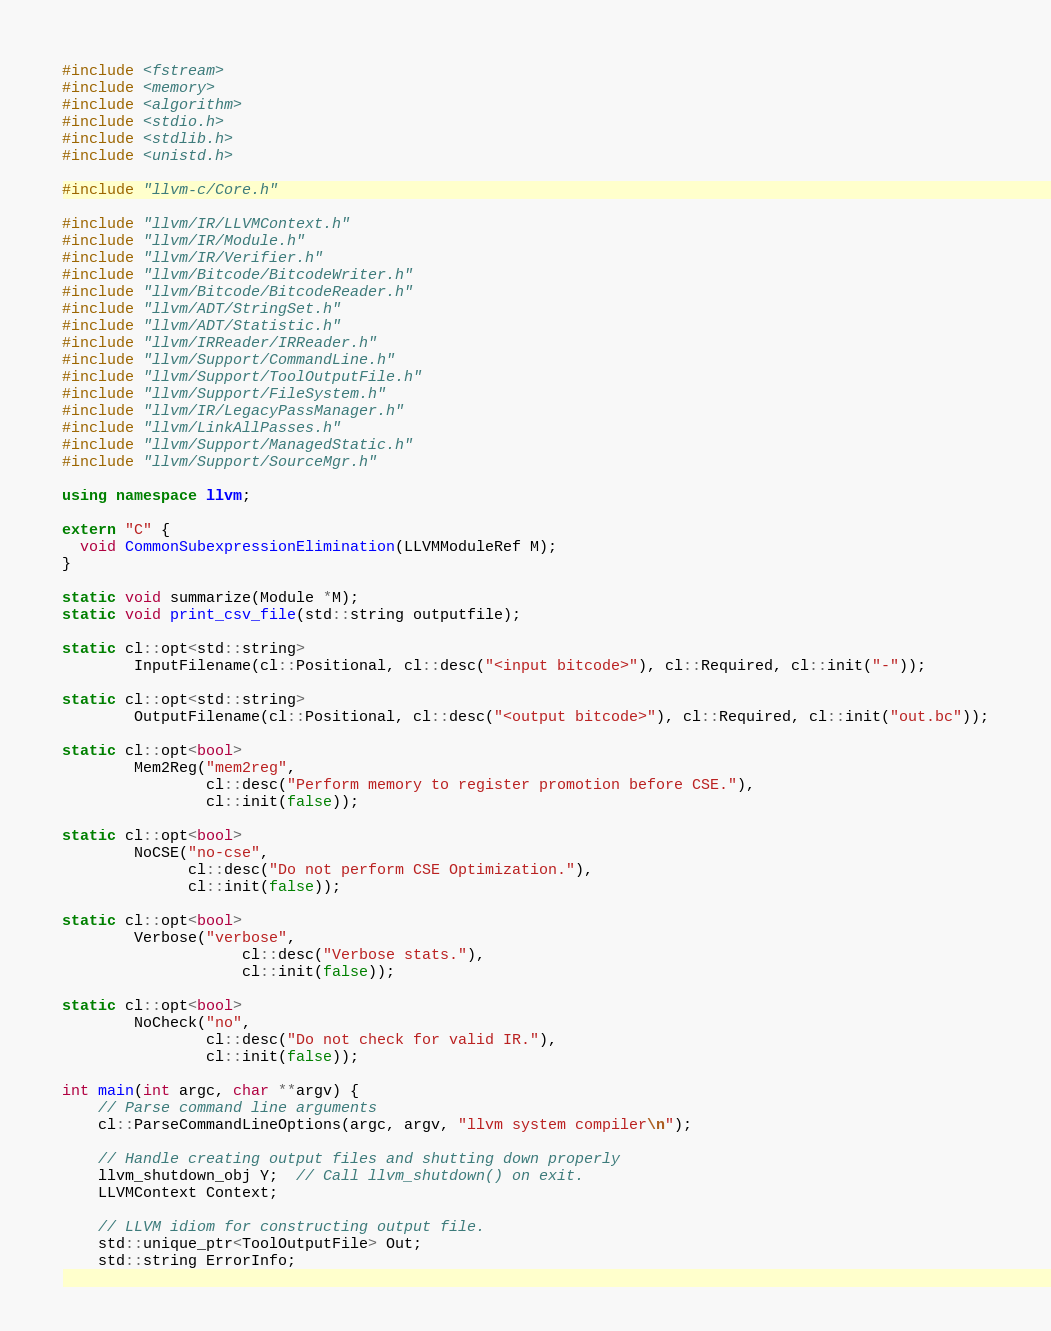Convert code to text. <code><loc_0><loc_0><loc_500><loc_500><_C++_>#include <fstream>
#include <memory>
#include <algorithm>
#include <stdio.h>
#include <stdlib.h>
#include <unistd.h>

#include "llvm-c/Core.h"

#include "llvm/IR/LLVMContext.h"
#include "llvm/IR/Module.h"
#include "llvm/IR/Verifier.h"
#include "llvm/Bitcode/BitcodeWriter.h"
#include "llvm/Bitcode/BitcodeReader.h"
#include "llvm/ADT/StringSet.h"
#include "llvm/ADT/Statistic.h"
#include "llvm/IRReader/IRReader.h"
#include "llvm/Support/CommandLine.h"
#include "llvm/Support/ToolOutputFile.h"
#include "llvm/Support/FileSystem.h"
#include "llvm/IR/LegacyPassManager.h"
#include "llvm/LinkAllPasses.h"
#include "llvm/Support/ManagedStatic.h"
#include "llvm/Support/SourceMgr.h"

using namespace llvm;

extern "C" {
  void CommonSubexpressionElimination(LLVMModuleRef M);
}

static void summarize(Module *M);
static void print_csv_file(std::string outputfile);

static cl::opt<std::string>
        InputFilename(cl::Positional, cl::desc("<input bitcode>"), cl::Required, cl::init("-"));

static cl::opt<std::string>
        OutputFilename(cl::Positional, cl::desc("<output bitcode>"), cl::Required, cl::init("out.bc"));

static cl::opt<bool>
        Mem2Reg("mem2reg",
                cl::desc("Perform memory to register promotion before CSE."),
                cl::init(false));

static cl::opt<bool>
        NoCSE("no-cse",
              cl::desc("Do not perform CSE Optimization."),
              cl::init(false));

static cl::opt<bool>
        Verbose("verbose",
                    cl::desc("Verbose stats."),
                    cl::init(false));

static cl::opt<bool>
        NoCheck("no",
                cl::desc("Do not check for valid IR."),
                cl::init(false));

int main(int argc, char **argv) {
    // Parse command line arguments
    cl::ParseCommandLineOptions(argc, argv, "llvm system compiler\n");

    // Handle creating output files and shutting down properly
    llvm_shutdown_obj Y;  // Call llvm_shutdown() on exit.
    LLVMContext Context;

    // LLVM idiom for constructing output file.
    std::unique_ptr<ToolOutputFile> Out;
    std::string ErrorInfo;</code> 